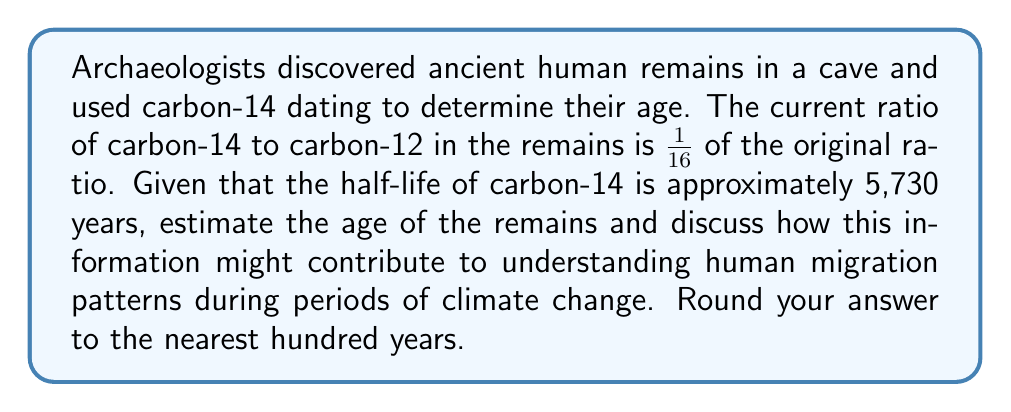Solve this math problem. To solve this problem, we'll use the radioactive decay formula and relate it to anthropological insights:

1) The radioactive decay formula is:

   $$N(t) = N_0 \cdot (1/2)^{t/t_{1/2}}$$

   Where:
   $N(t)$ is the amount at time $t$
   $N_0$ is the initial amount
   $t$ is the time elapsed
   $t_{1/2}$ is the half-life

2) We're given that the current ratio is 1/16 of the original, so:

   $$1/16 = (1/2)^{t/5730}$$

3) Taking the logarithm of both sides:

   $$\log(1/16) = \log((1/2)^{t/5730})$$
   $$-4\log(2) = (t/5730)\log(1/2)$$

4) Solving for $t$:

   $$t = 5730 \cdot \frac{4\log(2)}{-\log(1/2)} = 5730 \cdot 4 = 22,920$$

5) Rounding to the nearest hundred years:

   $$t \approx 22,900 \text{ years}$$

This result suggests that these human remains are from approximately 22,900 years ago, which corresponds to the Last Glacial Maximum (LGM). This period was characterized by extensive ice sheets and significantly colder temperatures globally.

From an anthropological perspective, this finding could provide valuable insights into human migration patterns during a period of extreme climate change:

1) It may indicate that humans were able to adapt to and survive in harsh, cold environments during the LGM.

2) The location of the cave relative to known ice sheet boundaries could suggest migration routes or refuge areas used by early humans during this period.

3) Comparing this data with other archaeological findings from the same time period in different regions could help map population movements in response to changing climate conditions.

4) The presence of human remains in this location at this time could indicate a shift in habitation patterns, possibly due to changing resource availability caused by climate fluctuations.

Understanding these migration patterns in relation to past climate changes can provide valuable insights into human adaptability and resilience, which may be relevant to current and future climate change scenarios.
Answer: 22,900 years 